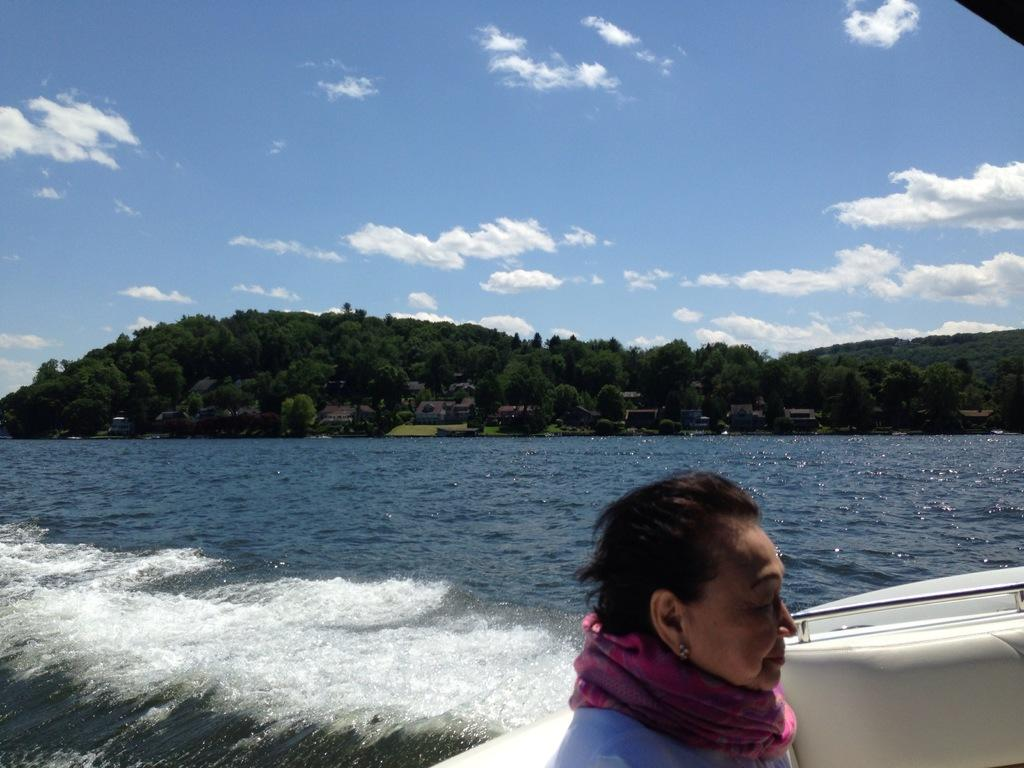Who is present in the image? There is a woman in the image. What is the woman doing in the image? The woman is on a boat. Where is the boat located? The boat is on water. What can be seen in the background of the image? There are trees and the sky visible in the background of the image. What is the condition of the sky in the image? Clouds are present in the sky. What type of animals can be seen at the zoo in the image? There is no zoo present in the image; it features a woman on a boat on water. Does the woman in the image express any feelings of hate towards the partner? There is no partner or any indication of feelings in the image; it only shows a woman on a boat on water. 